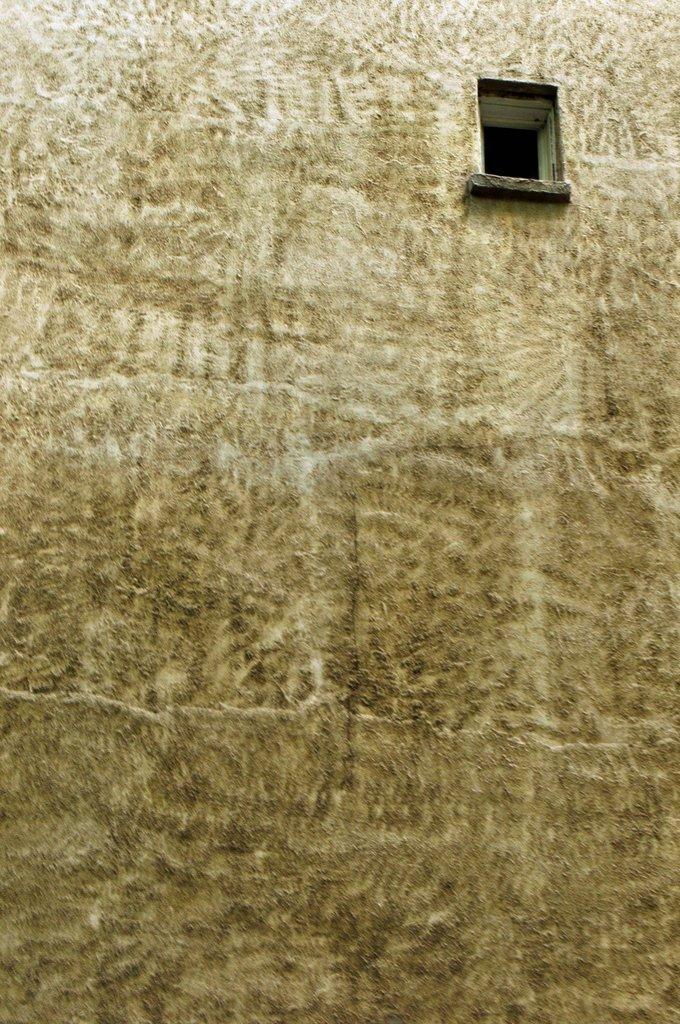Can you describe this image briefly? In the picture we can see the wall with a window. 